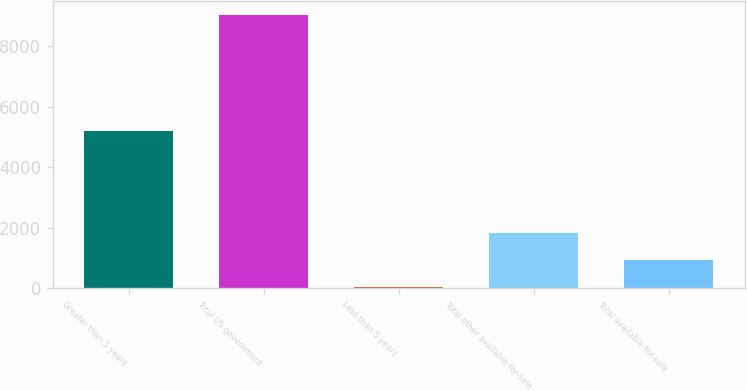<chart> <loc_0><loc_0><loc_500><loc_500><bar_chart><fcel>Greater than 5 years<fcel>Total US government<fcel>Less than 5 years<fcel>Total other available-for-sale<fcel>Total available-for-sale<nl><fcel>5207<fcel>9041<fcel>19<fcel>1823.4<fcel>921.2<nl></chart> 